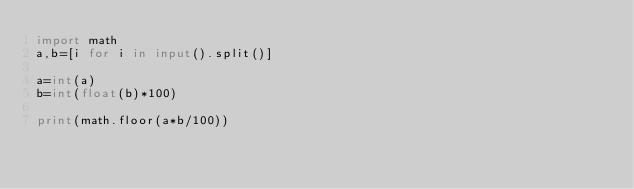Convert code to text. <code><loc_0><loc_0><loc_500><loc_500><_Python_>import math
a,b=[i for i in input().split()]

a=int(a)
b=int(float(b)*100)

print(math.floor(a*b/100))</code> 